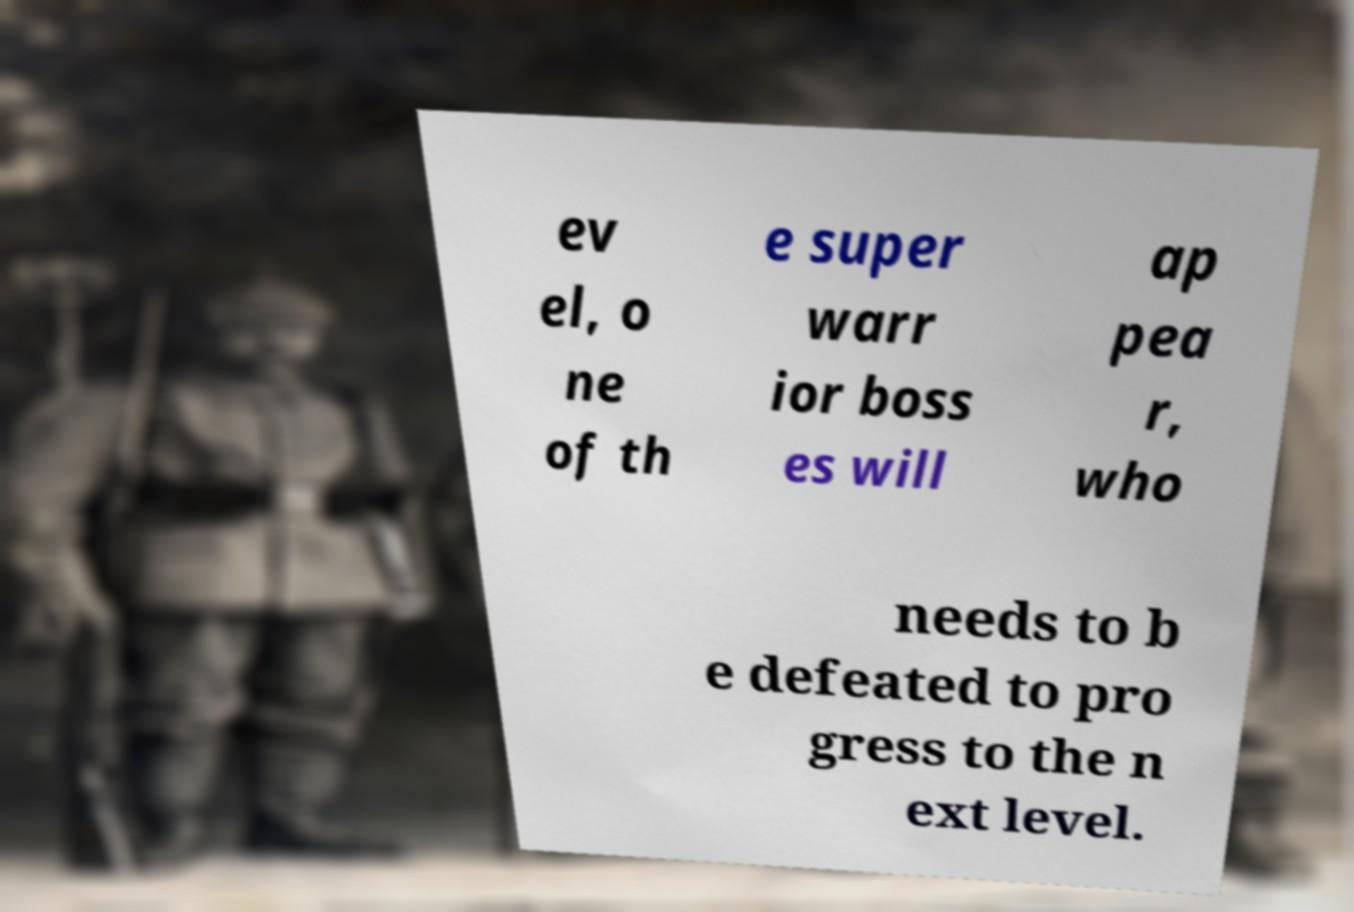I need the written content from this picture converted into text. Can you do that? ev el, o ne of th e super warr ior boss es will ap pea r, who needs to b e defeated to pro gress to the n ext level. 